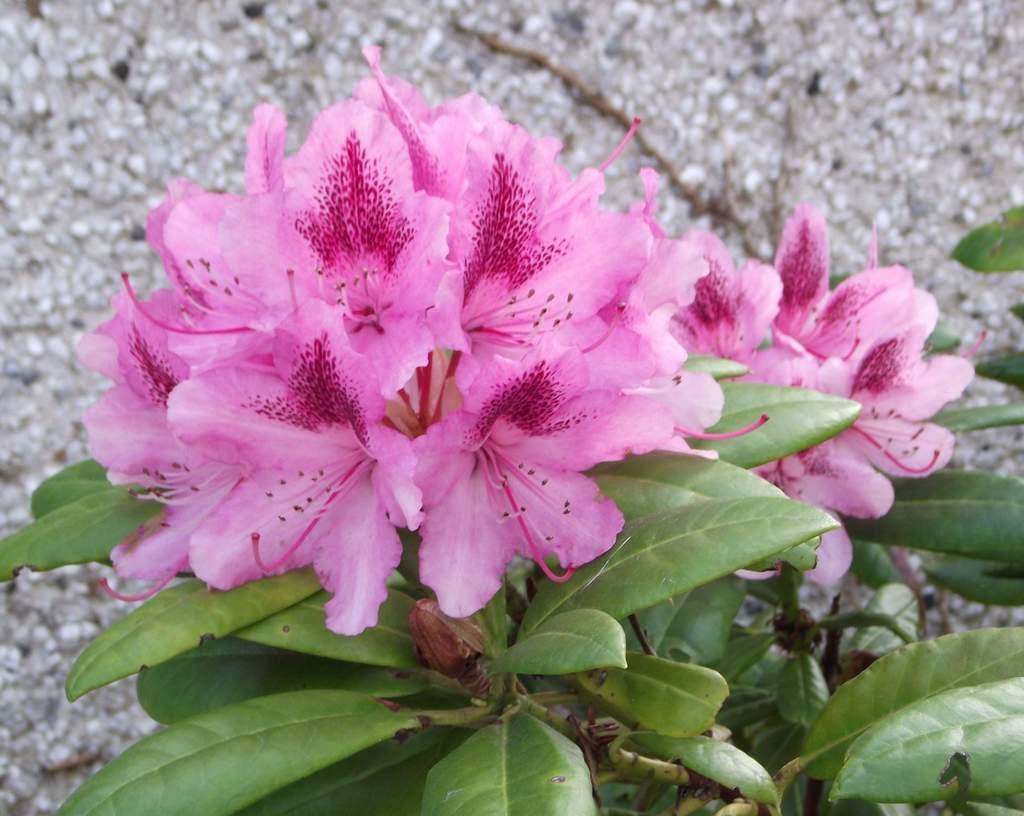How would you summarize this image in a sentence or two? In this image there are flowers, plants and few small stones. 